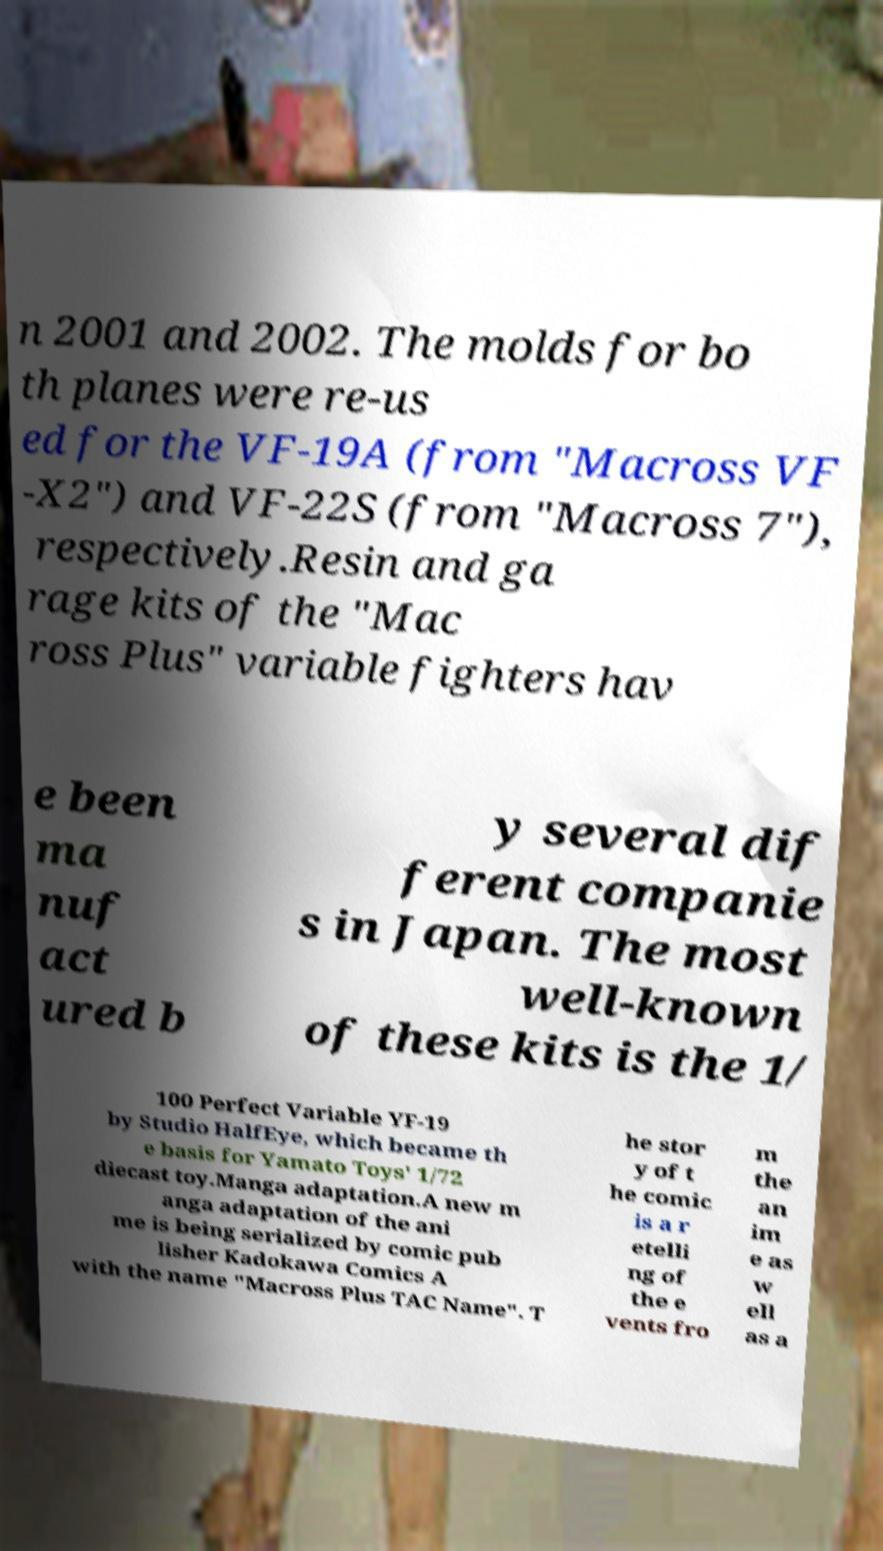Can you accurately transcribe the text from the provided image for me? n 2001 and 2002. The molds for bo th planes were re-us ed for the VF-19A (from "Macross VF -X2") and VF-22S (from "Macross 7"), respectively.Resin and ga rage kits of the "Mac ross Plus" variable fighters hav e been ma nuf act ured b y several dif ferent companie s in Japan. The most well-known of these kits is the 1/ 100 Perfect Variable YF-19 by Studio HalfEye, which became th e basis for Yamato Toys' 1/72 diecast toy.Manga adaptation.A new m anga adaptation of the ani me is being serialized by comic pub lisher Kadokawa Comics A with the name "Macross Plus TAC Name". T he stor y of t he comic is a r etelli ng of the e vents fro m the an im e as w ell as a 